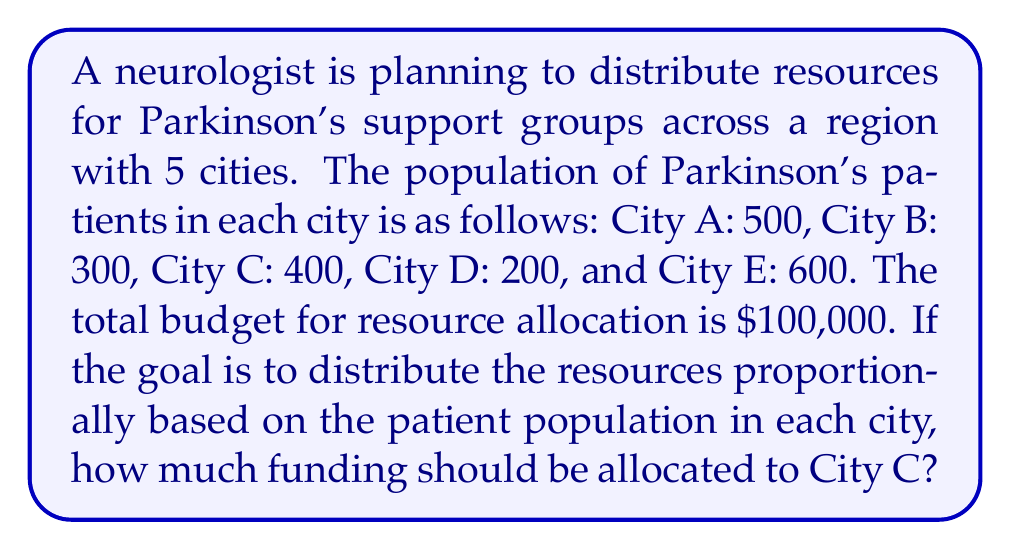Can you answer this question? To solve this problem, we'll follow these steps:

1. Calculate the total number of Parkinson's patients in the region:
   $$Total = 500 + 300 + 400 + 200 + 600 = 2000$$

2. Calculate the proportion of patients in City C:
   $$Proportion_C = \frac{400}{2000} = 0.2 = 20\%$$

3. Calculate the funding for City C based on this proportion:
   $$Funding_C = 0.2 \times \$100,000 = \$20,000$$

Therefore, City C should receive $20,000 in funding to maintain a proportional distribution of resources based on its patient population.
Answer: $20,000 